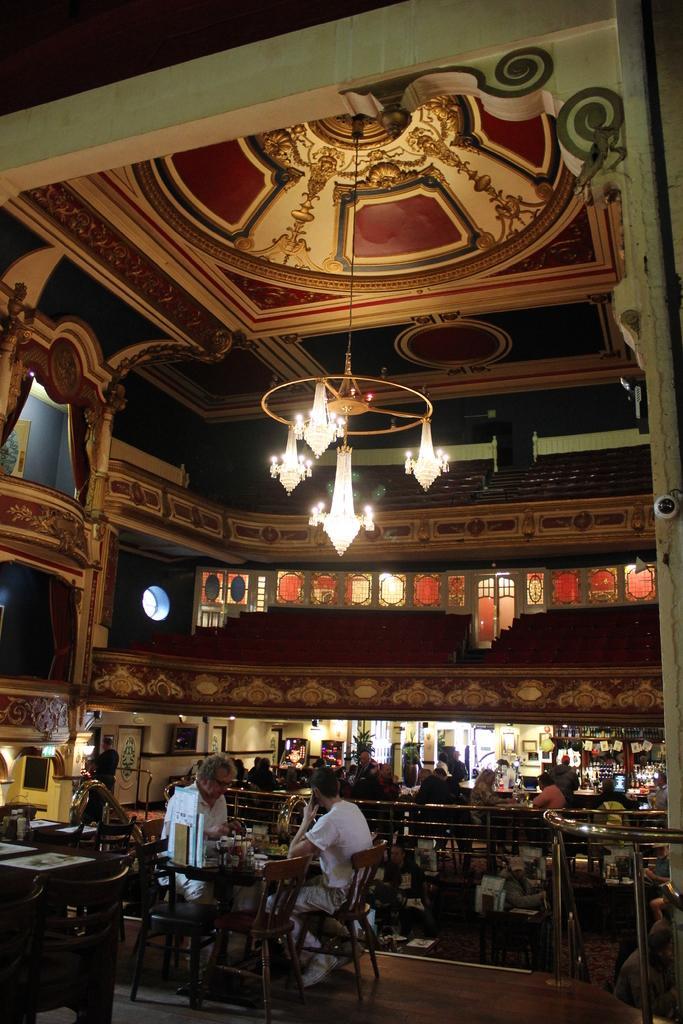How would you summarize this image in a sentence or two? This is a picture of a restaurant. In the foreground of the picture there are tables, on the tables there are menu card and dishes. There are two people seated in chairs in the foreground. In the background there are many people seated in chairs around the table. In the background there are windows, doors. On the top to the ceiling there is a chandelier. 